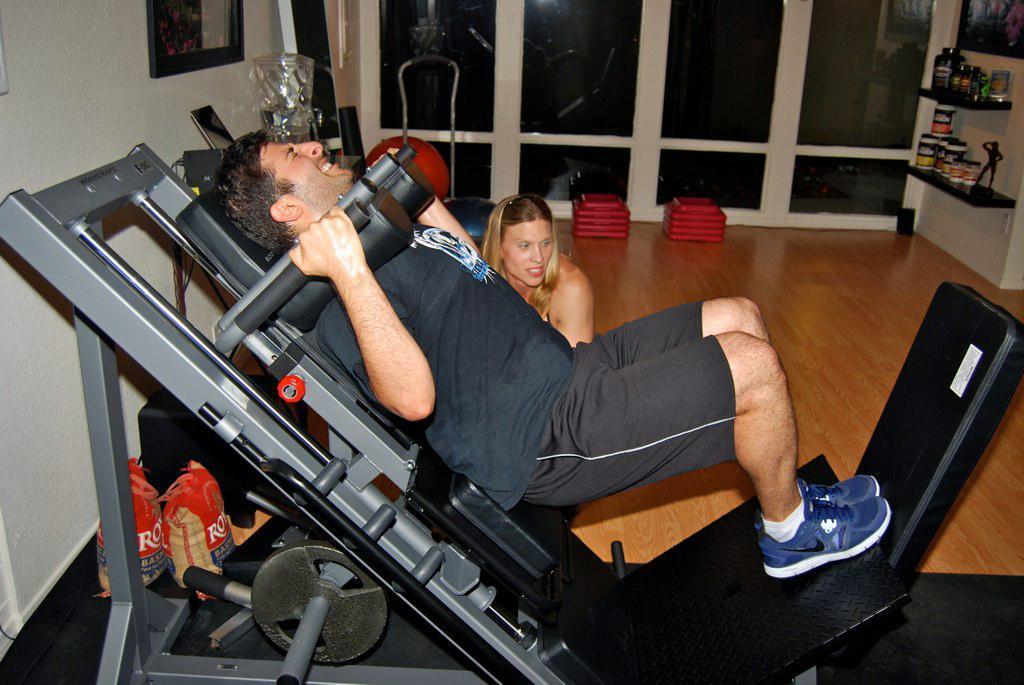How would you summarize this image in a sentence or two? In this image in the foreground there is one person who is doing some exercise, and in the background there is another woman. On the left side there are two bags, and in the background there is a window and some objects. And on the left side there are some photo frames on the wall, and in the center there are some objects. On the right side there are some bottles in a cupboard and a photo frame, at the bottom there is floor. 